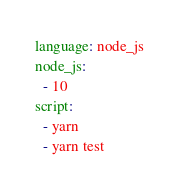Convert code to text. <code><loc_0><loc_0><loc_500><loc_500><_YAML_>language: node_js
node_js:
  - 10
script:
  - yarn
  - yarn test</code> 